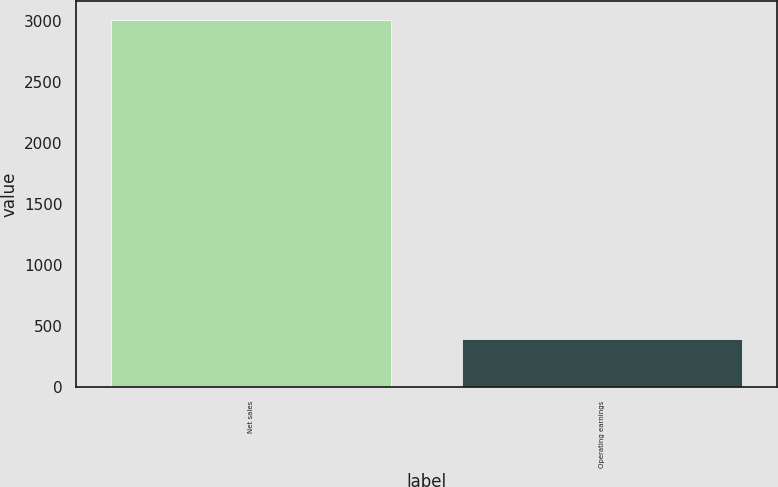Convert chart. <chart><loc_0><loc_0><loc_500><loc_500><bar_chart><fcel>Net sales<fcel>Operating earnings<nl><fcel>3012<fcel>393<nl></chart> 